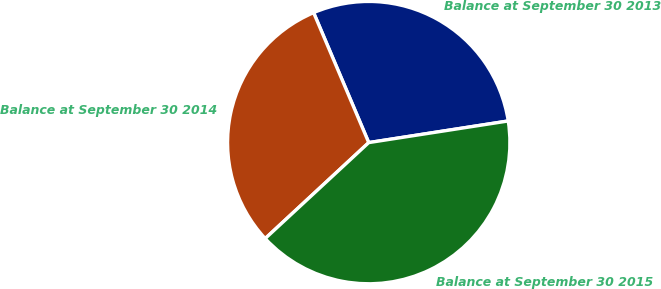<chart> <loc_0><loc_0><loc_500><loc_500><pie_chart><fcel>Balance at September 30 2013<fcel>Balance at September 30 2014<fcel>Balance at September 30 2015<nl><fcel>28.94%<fcel>30.51%<fcel>40.56%<nl></chart> 